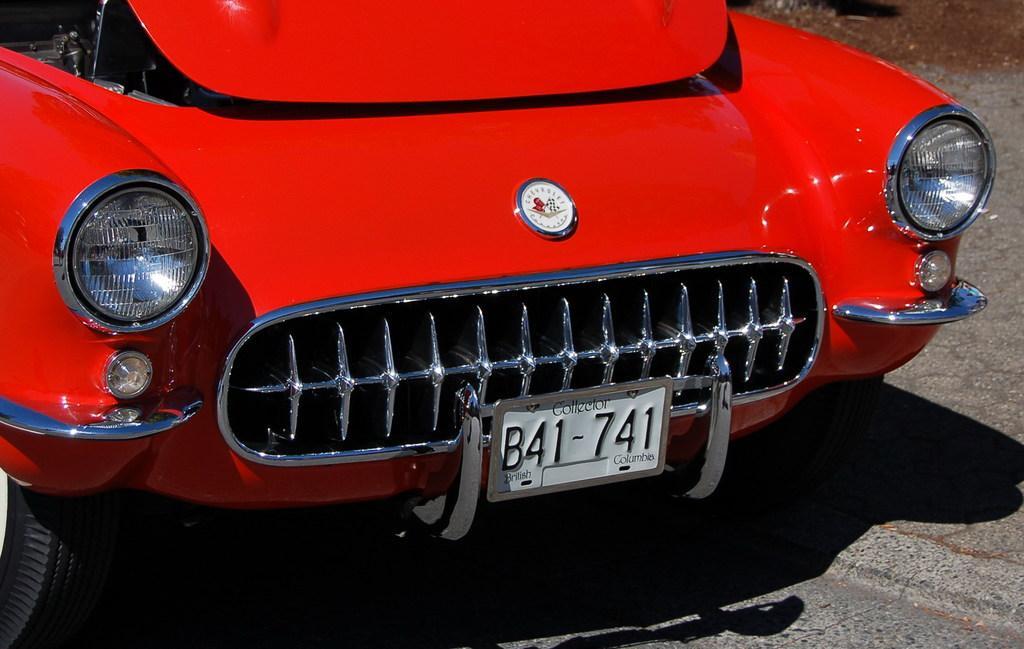Could you give a brief overview of what you see in this image? In the image there is red car with number plate, headlights. At the bottom of the image on the road there is a shadow of the car. 